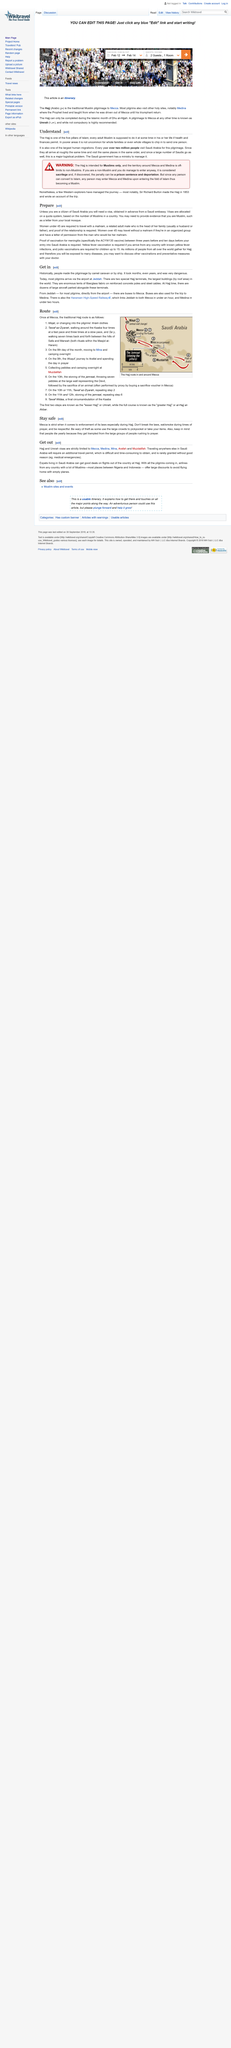Mention a couple of crucial points in this snapshot. Hajj and Umrah visas are only valid for use in the cities of Mecca, Medina, Mina, Arafah, and Muzdalifah. In preparing to travel to Saudi Arabia, obtaining a visa in advance from a Saudi embassy is an essential element. It is permissible for women over the age of 45 to travel without a mahram. Visas are issued according to a quota system, where the number of visas available is predetermined and allocated based on certain criteria such as country of origin, purpose of travel, and other factors. It is not appropriate to eat or smoke during times of prayer. 